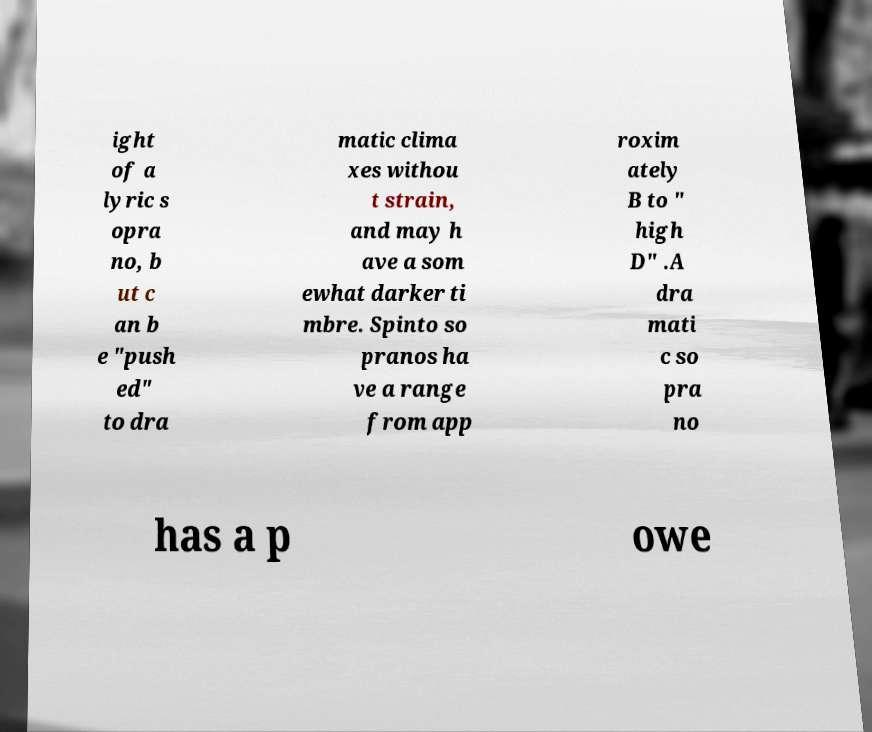What messages or text are displayed in this image? I need them in a readable, typed format. ight of a lyric s opra no, b ut c an b e "push ed" to dra matic clima xes withou t strain, and may h ave a som ewhat darker ti mbre. Spinto so pranos ha ve a range from app roxim ately B to " high D" .A dra mati c so pra no has a p owe 